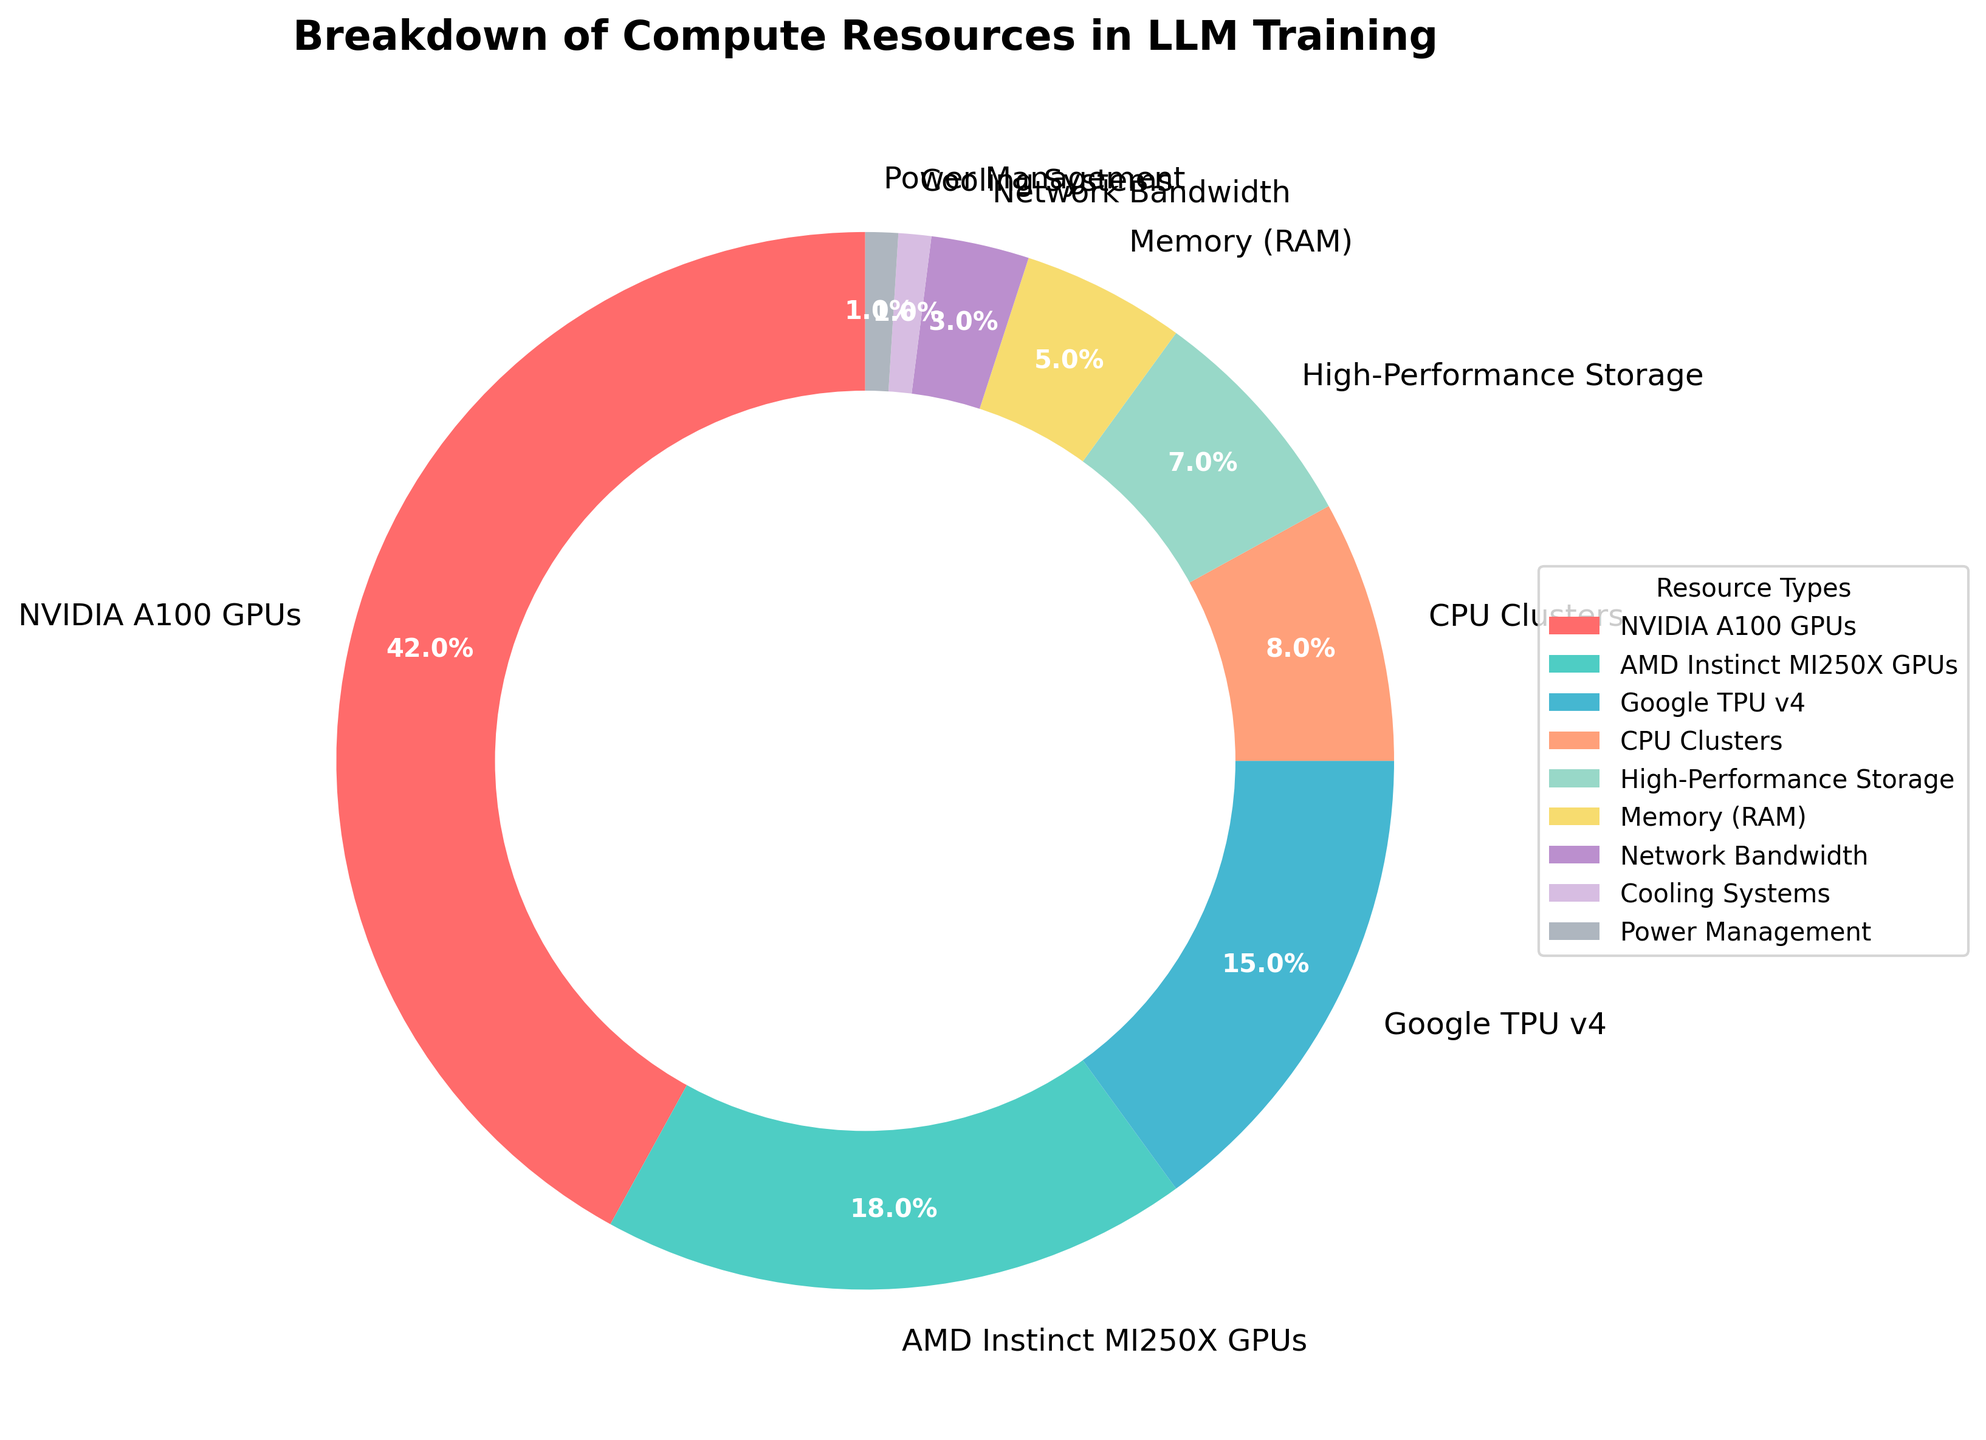What resource type has the largest portion in the pie chart? The pie chart segment that takes up the largest portion is labeled “NVIDIA A100 GPUs”, indicating that this resource type constitutes the largest chunk.
Answer: NVIDIA A100 GPUs Which two resource types together account for more than half of the resources used? Summing the percentages of the two largest segments, NVIDIA A100 GPUs (42%) and AMD Instinct MI250X GPUs (18%), gives a total of 60%, which is more than half.
Answer: NVIDIA A100 GPUs and AMD Instinct MI250X GPUs What's the combined percentage of CPU Clusters and High-Performance Storage? Adding the percentages of CPU Clusters (8%) and High-Performance Storage (7%) gives a total of 15%.
Answer: 15% How does the usage of Google TPU v4 compare to High-Performance Storage? The percentage for Google TPU v4 is 15%, while High-Performance Storage is 7%, indicating that Google TPU v4 usage is higher.
Answer: Google TPU v4 usage is higher What percentage of resources are represented by the three least utilized types? Summing up the percentages of Cooling Systems (1%), Power Management (1%), and Network Bandwidth (3%) gives a total of 5%.
Answer: 5% Which resource type has the smallest portion, and what is its percentage? The pie chart shows that both Cooling Systems and Power Management have the smallest segments, each comprising 1%.
Answer: Cooling Systems and Power Management; 1% What is the second largest resource type used and what is its percentage? The second largest segment in the pie chart is AMD Instinct MI250X GPUs, with 18%.
Answer: AMD Instinct MI250X GPUs; 18% By how much does the percentage of Memory (RAM) differ from the percentage of Network Bandwidth? The percentage for Memory (RAM) is 5%, and for Network Bandwidth, it is 3%. The difference is 5% - 3% = 2%.
Answer: 2% Which resource type shown in red, and what resource does it represent? The pie chart segment that is colored red corresponds to the label indicating "NVIDIA A100 GPUs".
Answer: NVIDIA A100 GPUs What's the combined percentage of the three most utilized resource types? Adding the percentages of the top three segments, NVIDIA A100 GPUs (42%), AMD Instinct MI250X GPUs (18%), and Google TPU v4 (15%) gives us 42% + 18% + 15% = 75%.
Answer: 75% 